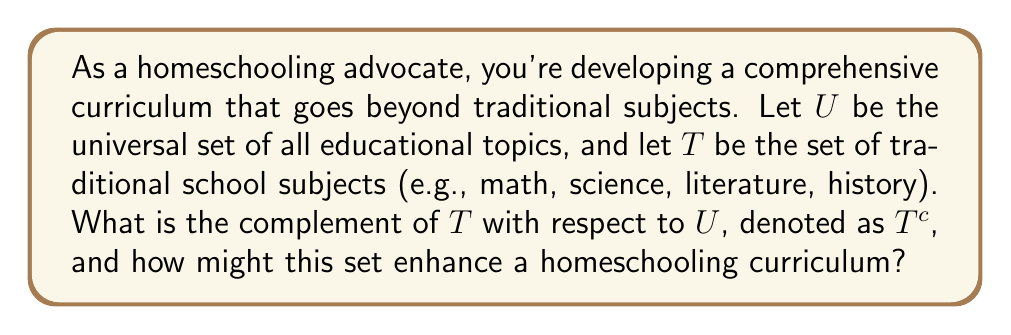Provide a solution to this math problem. To solve this problem, we need to understand the concept of set complement and its application to educational topics:

1) The universal set $U$ contains all possible educational topics.

2) Set $T$ represents traditional school subjects:
   $T = \{math, science, literature, history, ...\}$

3) The complement of $T$, denoted as $T^c$, is defined as:
   $T^c = \{x \in U : x \notin T\}$

This means $T^c$ contains all elements in $U$ that are not in $T$.

4) $T^c$ would include non-traditional subjects and skills such as:
   - Life skills (e.g., financial literacy, cooking)
   - Technology and coding
   - Entrepreneurship
   - Emotional intelligence
   - Creative arts beyond traditional fine arts
   - Practical trades and vocational skills
   - Environmental studies and sustainability
   - Mindfulness and mental health
   - Cultural studies and languages beyond typical offerings

5) In set theory notation:
   $T^c = U \setminus T$

Where $\setminus$ represents the set difference operation.

6) Visualizing this with a Venn diagram:

[asy]
unitsize(1cm);
draw(circle((0,0),3));
draw(circle((0,0),2));
label("$U$", (3,3));
label("$T$", (0,0));
label("$T^c$", (2.5,0));
[/asy]

This complement set $T^c$ is valuable for homeschooling as it represents the diverse, real-world topics often overlooked in traditional education, allowing for a more holistic and personalized learning experience.
Answer: $T^c = U \setminus T = \{x \in U : x \notin T\}$, representing all educational topics not typically included in traditional school curricula. This set enhances homeschooling by incorporating diverse, practical, and personalized learning experiences beyond conventional subjects. 